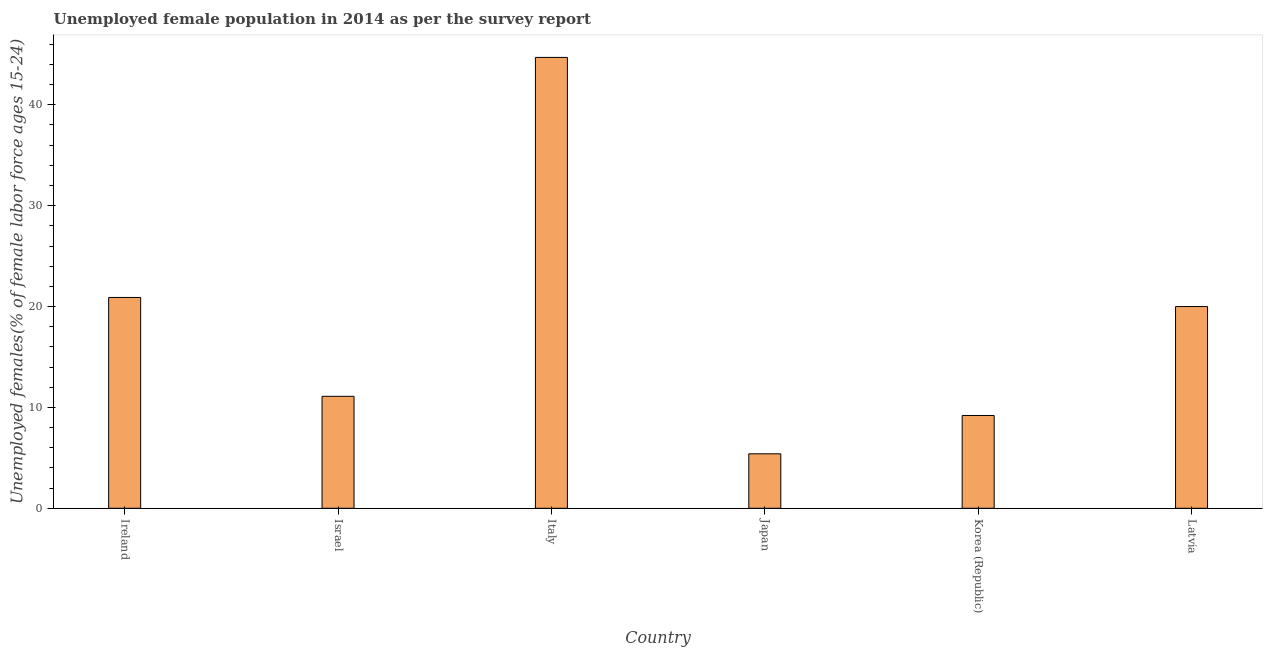Does the graph contain any zero values?
Offer a terse response. No. Does the graph contain grids?
Provide a short and direct response. No. What is the title of the graph?
Your response must be concise. Unemployed female population in 2014 as per the survey report. What is the label or title of the X-axis?
Your response must be concise. Country. What is the label or title of the Y-axis?
Keep it short and to the point. Unemployed females(% of female labor force ages 15-24). What is the unemployed female youth in Israel?
Your answer should be compact. 11.1. Across all countries, what is the maximum unemployed female youth?
Give a very brief answer. 44.7. Across all countries, what is the minimum unemployed female youth?
Your response must be concise. 5.4. In which country was the unemployed female youth minimum?
Keep it short and to the point. Japan. What is the sum of the unemployed female youth?
Make the answer very short. 111.3. What is the average unemployed female youth per country?
Ensure brevity in your answer.  18.55. What is the median unemployed female youth?
Ensure brevity in your answer.  15.55. In how many countries, is the unemployed female youth greater than 44 %?
Your answer should be compact. 1. What is the ratio of the unemployed female youth in Italy to that in Japan?
Your answer should be very brief. 8.28. Is the unemployed female youth in Ireland less than that in Italy?
Your answer should be compact. Yes. What is the difference between the highest and the second highest unemployed female youth?
Your response must be concise. 23.8. Is the sum of the unemployed female youth in Ireland and Italy greater than the maximum unemployed female youth across all countries?
Give a very brief answer. Yes. What is the difference between the highest and the lowest unemployed female youth?
Keep it short and to the point. 39.3. What is the difference between two consecutive major ticks on the Y-axis?
Keep it short and to the point. 10. Are the values on the major ticks of Y-axis written in scientific E-notation?
Provide a succinct answer. No. What is the Unemployed females(% of female labor force ages 15-24) in Ireland?
Offer a terse response. 20.9. What is the Unemployed females(% of female labor force ages 15-24) of Israel?
Offer a very short reply. 11.1. What is the Unemployed females(% of female labor force ages 15-24) in Italy?
Your answer should be very brief. 44.7. What is the Unemployed females(% of female labor force ages 15-24) of Japan?
Your answer should be compact. 5.4. What is the Unemployed females(% of female labor force ages 15-24) in Korea (Republic)?
Provide a short and direct response. 9.2. What is the Unemployed females(% of female labor force ages 15-24) in Latvia?
Give a very brief answer. 20. What is the difference between the Unemployed females(% of female labor force ages 15-24) in Ireland and Italy?
Keep it short and to the point. -23.8. What is the difference between the Unemployed females(% of female labor force ages 15-24) in Ireland and Korea (Republic)?
Provide a short and direct response. 11.7. What is the difference between the Unemployed females(% of female labor force ages 15-24) in Ireland and Latvia?
Keep it short and to the point. 0.9. What is the difference between the Unemployed females(% of female labor force ages 15-24) in Israel and Italy?
Offer a very short reply. -33.6. What is the difference between the Unemployed females(% of female labor force ages 15-24) in Israel and Japan?
Ensure brevity in your answer.  5.7. What is the difference between the Unemployed females(% of female labor force ages 15-24) in Italy and Japan?
Offer a very short reply. 39.3. What is the difference between the Unemployed females(% of female labor force ages 15-24) in Italy and Korea (Republic)?
Provide a short and direct response. 35.5. What is the difference between the Unemployed females(% of female labor force ages 15-24) in Italy and Latvia?
Provide a succinct answer. 24.7. What is the difference between the Unemployed females(% of female labor force ages 15-24) in Japan and Latvia?
Your answer should be very brief. -14.6. What is the ratio of the Unemployed females(% of female labor force ages 15-24) in Ireland to that in Israel?
Your answer should be very brief. 1.88. What is the ratio of the Unemployed females(% of female labor force ages 15-24) in Ireland to that in Italy?
Ensure brevity in your answer.  0.47. What is the ratio of the Unemployed females(% of female labor force ages 15-24) in Ireland to that in Japan?
Ensure brevity in your answer.  3.87. What is the ratio of the Unemployed females(% of female labor force ages 15-24) in Ireland to that in Korea (Republic)?
Your answer should be very brief. 2.27. What is the ratio of the Unemployed females(% of female labor force ages 15-24) in Ireland to that in Latvia?
Provide a succinct answer. 1.04. What is the ratio of the Unemployed females(% of female labor force ages 15-24) in Israel to that in Italy?
Provide a succinct answer. 0.25. What is the ratio of the Unemployed females(% of female labor force ages 15-24) in Israel to that in Japan?
Your response must be concise. 2.06. What is the ratio of the Unemployed females(% of female labor force ages 15-24) in Israel to that in Korea (Republic)?
Give a very brief answer. 1.21. What is the ratio of the Unemployed females(% of female labor force ages 15-24) in Israel to that in Latvia?
Ensure brevity in your answer.  0.56. What is the ratio of the Unemployed females(% of female labor force ages 15-24) in Italy to that in Japan?
Offer a very short reply. 8.28. What is the ratio of the Unemployed females(% of female labor force ages 15-24) in Italy to that in Korea (Republic)?
Keep it short and to the point. 4.86. What is the ratio of the Unemployed females(% of female labor force ages 15-24) in Italy to that in Latvia?
Provide a short and direct response. 2.23. What is the ratio of the Unemployed females(% of female labor force ages 15-24) in Japan to that in Korea (Republic)?
Ensure brevity in your answer.  0.59. What is the ratio of the Unemployed females(% of female labor force ages 15-24) in Japan to that in Latvia?
Offer a terse response. 0.27. What is the ratio of the Unemployed females(% of female labor force ages 15-24) in Korea (Republic) to that in Latvia?
Your answer should be compact. 0.46. 